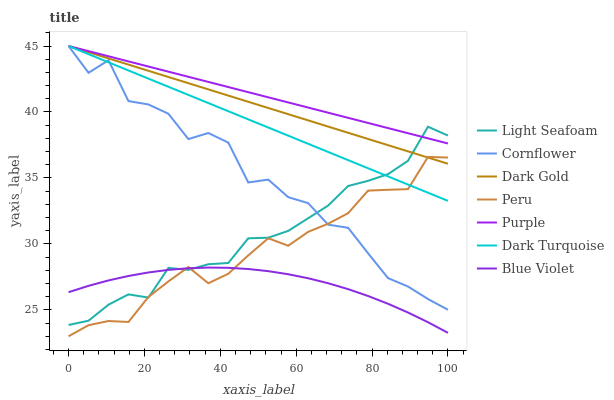Does Blue Violet have the minimum area under the curve?
Answer yes or no. Yes. Does Purple have the maximum area under the curve?
Answer yes or no. Yes. Does Dark Gold have the minimum area under the curve?
Answer yes or no. No. Does Dark Gold have the maximum area under the curve?
Answer yes or no. No. Is Purple the smoothest?
Answer yes or no. Yes. Is Cornflower the roughest?
Answer yes or no. Yes. Is Dark Gold the smoothest?
Answer yes or no. No. Is Dark Gold the roughest?
Answer yes or no. No. Does Peru have the lowest value?
Answer yes or no. Yes. Does Dark Gold have the lowest value?
Answer yes or no. No. Does Dark Turquoise have the highest value?
Answer yes or no. Yes. Does Peru have the highest value?
Answer yes or no. No. Is Blue Violet less than Dark Gold?
Answer yes or no. Yes. Is Dark Gold greater than Blue Violet?
Answer yes or no. Yes. Does Dark Gold intersect Peru?
Answer yes or no. Yes. Is Dark Gold less than Peru?
Answer yes or no. No. Is Dark Gold greater than Peru?
Answer yes or no. No. Does Blue Violet intersect Dark Gold?
Answer yes or no. No. 